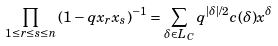<formula> <loc_0><loc_0><loc_500><loc_500>\prod _ { 1 \leq r \leq s \leq n } \left ( 1 - q x _ { r } x _ { s } \right ) ^ { - 1 } = \sum _ { \delta \in L _ { C } } q ^ { \left | \delta \right | / 2 } c ( \delta ) x ^ { \delta }</formula> 